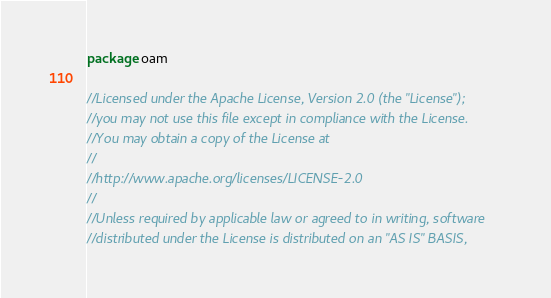Convert code to text. <code><loc_0><loc_0><loc_500><loc_500><_Go_>package oam

//Licensed under the Apache License, Version 2.0 (the "License");
//you may not use this file except in compliance with the License.
//You may obtain a copy of the License at
//
//http://www.apache.org/licenses/LICENSE-2.0
//
//Unless required by applicable law or agreed to in writing, software
//distributed under the License is distributed on an "AS IS" BASIS,</code> 